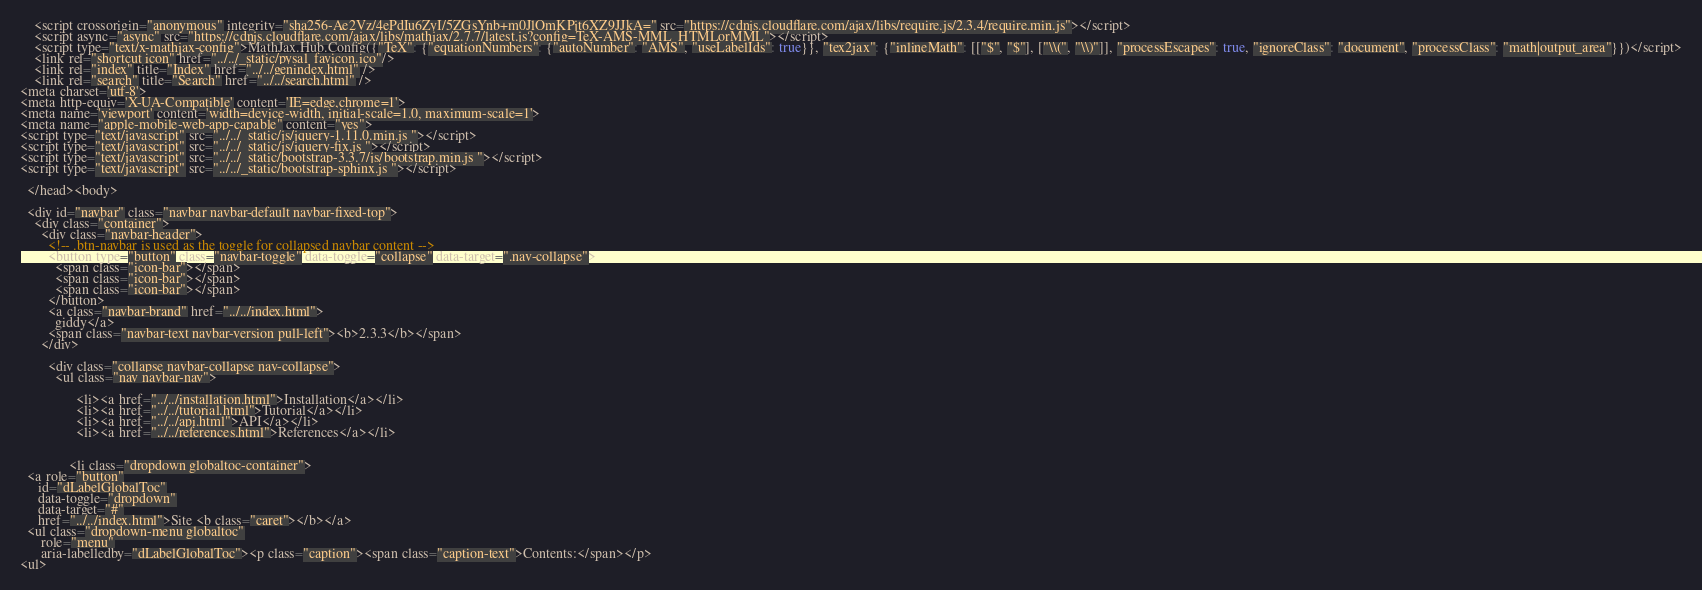<code> <loc_0><loc_0><loc_500><loc_500><_HTML_>    <script crossorigin="anonymous" integrity="sha256-Ae2Vz/4ePdIu6ZyI/5ZGsYnb+m0JlOmKPjt6XZ9JJkA=" src="https://cdnjs.cloudflare.com/ajax/libs/require.js/2.3.4/require.min.js"></script>
    <script async="async" src="https://cdnjs.cloudflare.com/ajax/libs/mathjax/2.7.7/latest.js?config=TeX-AMS-MML_HTMLorMML"></script>
    <script type="text/x-mathjax-config">MathJax.Hub.Config({"TeX": {"equationNumbers": {"autoNumber": "AMS", "useLabelIds": true}}, "tex2jax": {"inlineMath": [["$", "$"], ["\\(", "\\)"]], "processEscapes": true, "ignoreClass": "document", "processClass": "math|output_area"}})</script>
    <link rel="shortcut icon" href="../../_static/pysal_favicon.ico"/>
    <link rel="index" title="Index" href="../../genindex.html" />
    <link rel="search" title="Search" href="../../search.html" />
<meta charset='utf-8'>
<meta http-equiv='X-UA-Compatible' content='IE=edge,chrome=1'>
<meta name='viewport' content='width=device-width, initial-scale=1.0, maximum-scale=1'>
<meta name="apple-mobile-web-app-capable" content="yes">
<script type="text/javascript" src="../../_static/js/jquery-1.11.0.min.js "></script>
<script type="text/javascript" src="../../_static/js/jquery-fix.js "></script>
<script type="text/javascript" src="../../_static/bootstrap-3.3.7/js/bootstrap.min.js "></script>
<script type="text/javascript" src="../../_static/bootstrap-sphinx.js "></script>

  </head><body>

  <div id="navbar" class="navbar navbar-default navbar-fixed-top">
    <div class="container">
      <div class="navbar-header">
        <!-- .btn-navbar is used as the toggle for collapsed navbar content -->
        <button type="button" class="navbar-toggle" data-toggle="collapse" data-target=".nav-collapse">
          <span class="icon-bar"></span>
          <span class="icon-bar"></span>
          <span class="icon-bar"></span>
        </button>
        <a class="navbar-brand" href="../../index.html">
          giddy</a>
        <span class="navbar-text navbar-version pull-left"><b>2.3.3</b></span>
      </div>

        <div class="collapse navbar-collapse nav-collapse">
          <ul class="nav navbar-nav">
            
                <li><a href="../../installation.html">Installation</a></li>
                <li><a href="../../tutorial.html">Tutorial</a></li>
                <li><a href="../../api.html">API</a></li>
                <li><a href="../../references.html">References</a></li>
            
            
              <li class="dropdown globaltoc-container">
  <a role="button"
     id="dLabelGlobalToc"
     data-toggle="dropdown"
     data-target="#"
     href="../../index.html">Site <b class="caret"></b></a>
  <ul class="dropdown-menu globaltoc"
      role="menu"
      aria-labelledby="dLabelGlobalToc"><p class="caption"><span class="caption-text">Contents:</span></p>
<ul></code> 